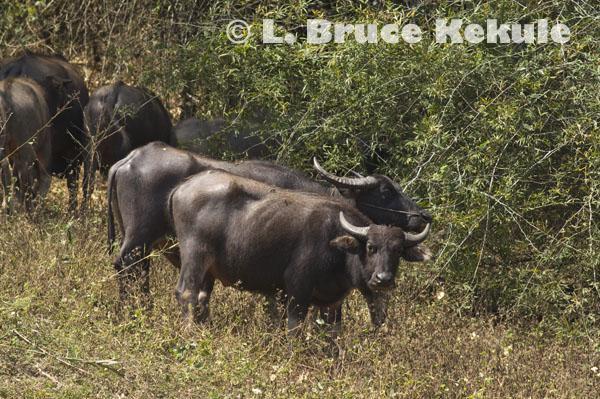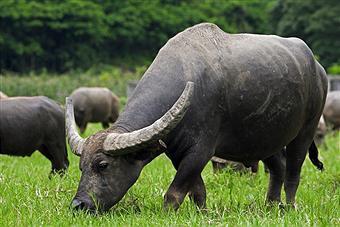The first image is the image on the left, the second image is the image on the right. Given the left and right images, does the statement "A person wearing bright blue is in the middle of a large group of oxen in one image." hold true? Answer yes or no. No. The first image is the image on the left, the second image is the image on the right. Evaluate the accuracy of this statement regarding the images: "There is at one man with a blue shirt in the middle of at least 10 horned oxes.". Is it true? Answer yes or no. No. 